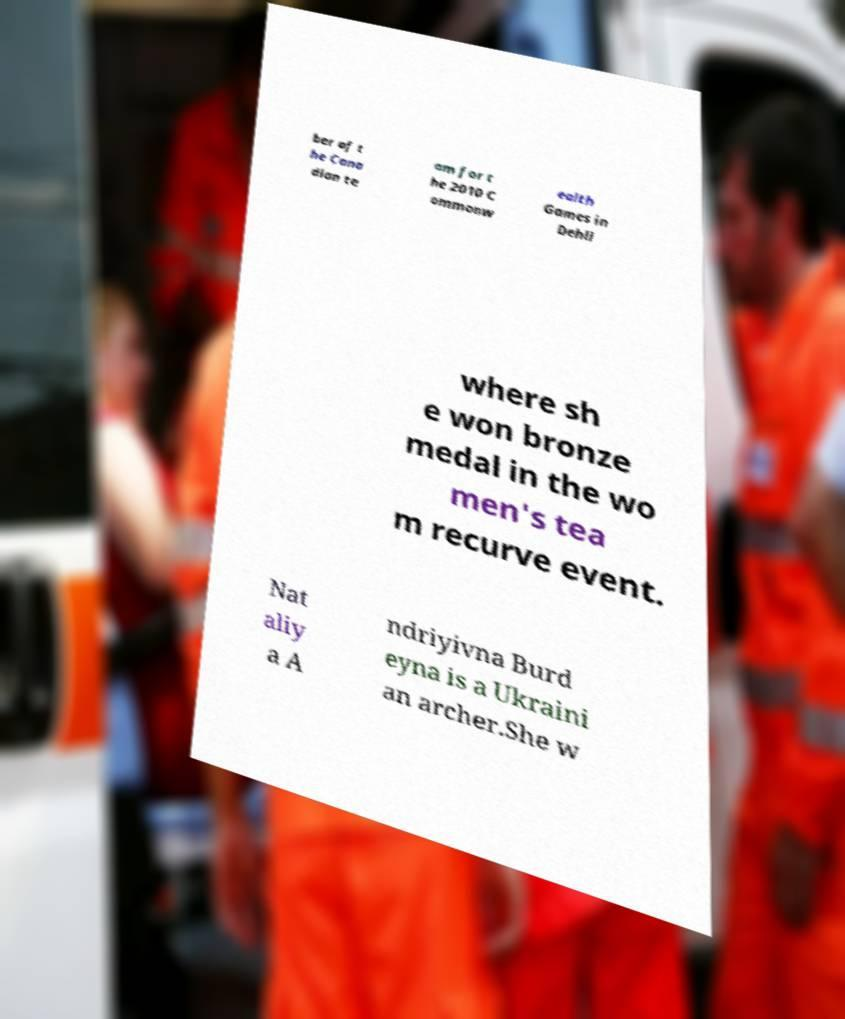Could you assist in decoding the text presented in this image and type it out clearly? ber of t he Cana dian te am for t he 2010 C ommonw ealth Games in Dehli where sh e won bronze medal in the wo men's tea m recurve event. Nat aliy a A ndriyivna Burd eyna is a Ukraini an archer.She w 